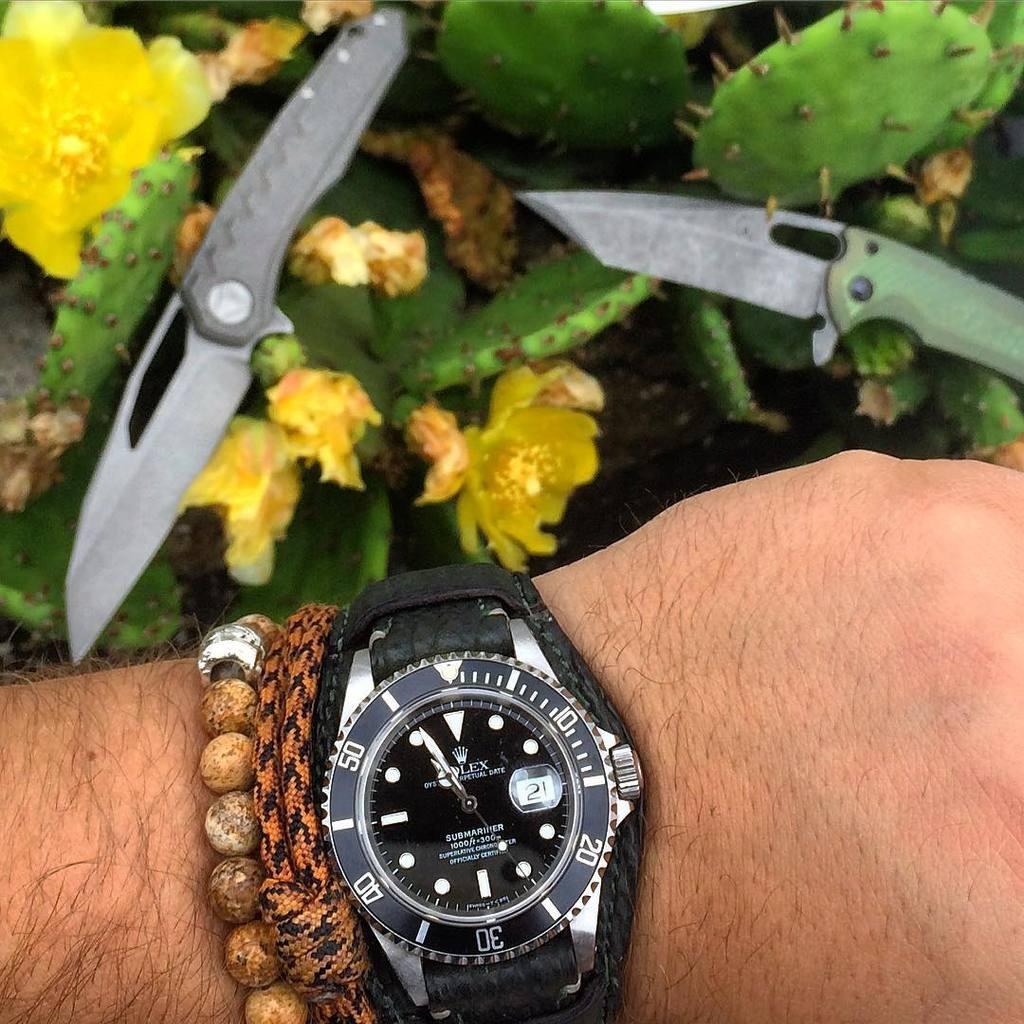<image>
Share a concise interpretation of the image provided. A watch on a mans wrist that says submariner on it. 